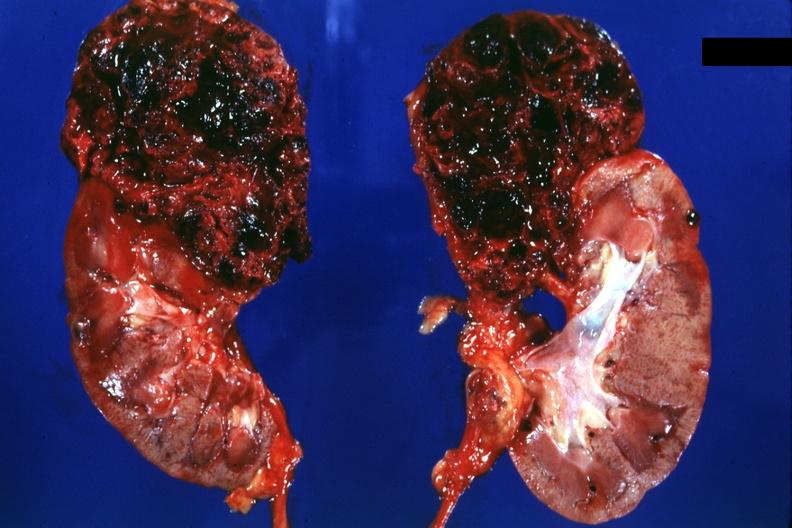does this image show two halves of kidney with superior pole very hemorrhagic tumor?
Answer the question using a single word or phrase. Yes 